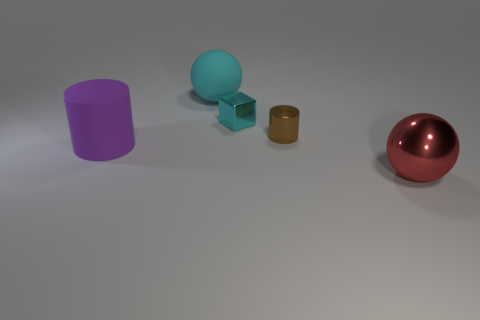Add 4 small cyan shiny things. How many objects exist? 9 Subtract all purple cylinders. How many cylinders are left? 1 Subtract 1 blocks. How many blocks are left? 0 Subtract 0 gray spheres. How many objects are left? 5 Subtract all cylinders. How many objects are left? 3 Subtract all gray cylinders. Subtract all blue spheres. How many cylinders are left? 2 Subtract all green blocks. How many cyan balls are left? 1 Subtract all large rubber cylinders. Subtract all big red cubes. How many objects are left? 4 Add 4 big matte objects. How many big matte objects are left? 6 Add 5 tiny cyan things. How many tiny cyan things exist? 6 